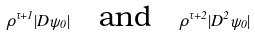<formula> <loc_0><loc_0><loc_500><loc_500>\rho ^ { \tau + 1 } | D \psi _ { 0 } | \quad \text {and} \quad \rho ^ { \tau + 2 } | D ^ { 2 } \psi _ { 0 } |</formula> 